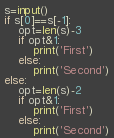Convert code to text. <code><loc_0><loc_0><loc_500><loc_500><_Python_>s=input()
if s[0]==s[-1]:
    opt=len(s)-3 
    if opt&1: 
        print('First')
    else:
        print('Second')
else: 
    opt=len(s)-2 
    if opt&1:
        print('First')
    else:
        print('Second')</code> 